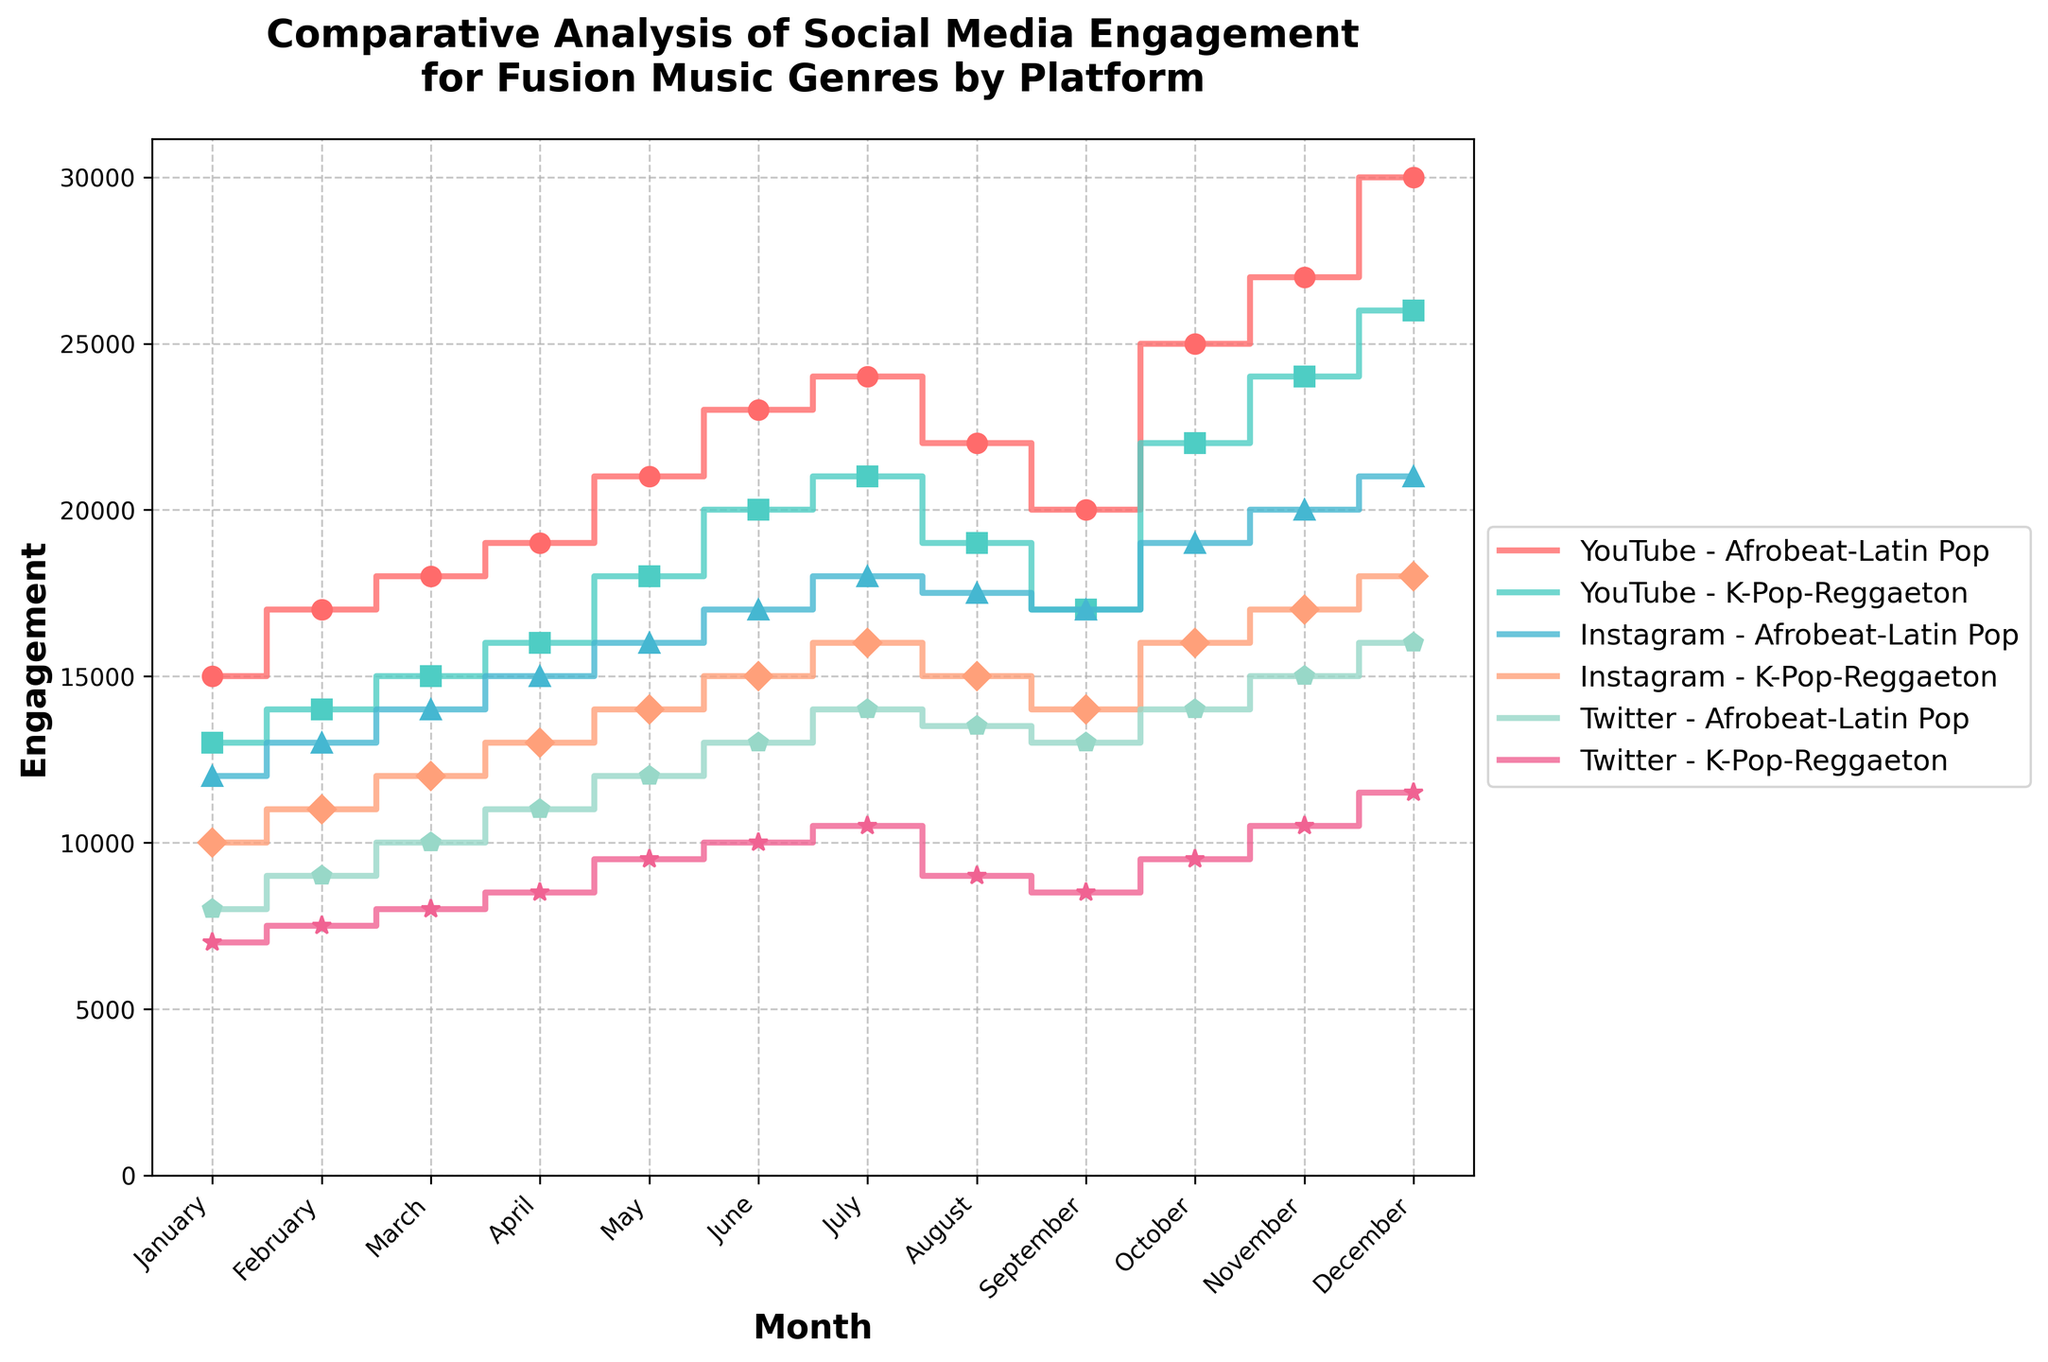What is the title of the figure? The title is always found at the top of the figure, looking at the figure, the title stands out clearly.
Answer: Comparative Analysis of Social Media Engagement for Fusion Music Genres by Platform Which platform and genre combination has the highest engagement in December? To find the highest engagement in December, look at the data points for December across all platform and genre combinations. The highest point corresponds to YouTube - Afrobeat-Latin Pop.
Answer: YouTube - Afrobeat-Latin Pop How does the engagement of Afrobeat-Latin Pop on Instagram change from January to December? To determine the change, compare January and December values. Afrobeat-Latin Pop on Instagram starts at 12,000 in January and ends at 21,000 in December, showing a steady increase over the months.
Answer: It increases from 12,000 to 21,000 Which genre shows more growth on Twitter, Afrobeat-Latin Pop or K-Pop-Reggaeton? Calculate the difference between the January and December engagement values for both genres on Twitter. For Afrobeat-Latin Pop, the increase is from 8,000 to 16,000 (+8,000), and for K-Pop-Reggaeton, it goes from 7,000 to 11,500 (+4,500).
Answer: Afrobeat-Latin Pop What is the average engagement for K-Pop-Reggaeton on YouTube from January to December? Sum the monthly engagement values from January to December for K-Pop-Reggaeton on YouTube, then divide by 12. The engagements are 13,000, 14,000, 15,000, 16,000, 18,000, 20,000, 21,000, 19,000, 17,000, 22,000, 24,000, 26,000. Sum = 215,000, average = 215,000/12.
Answer: 17,917 Which month shows the highest engagement for Instagram as a whole? For each month, sum the engagement values for both genres on Instagram. Find the maximum total engagement month. October has the highest sum (19,000 + 16,000 = 35,000).
Answer: October Compare the engagement patterns of Afrobeat-Latin Pop on YouTube and Twitter. What trend do you notice? To compare, observe the step patterns in both YouTube and Twitter for Afrobeat-Latin Pop. YouTube shows a sharp increase with consistent monthly growth, while Twitter shows a steady but slower upward trend.
Answer: YouTube shows sharper increases compared to Twitter In which month does YouTube see a noticeable spike for Afrobeat-Latin Pop? Identify the month-by-month engagement values and look for a significant jump. A noticeable spike is observed from September (20,000) to October (25,000).
Answer: October 